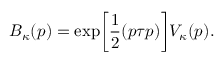<formula> <loc_0><loc_0><loc_500><loc_500>B _ { \kappa } ( p ) = \exp \left [ \frac { 1 } { 2 } ( p \tau p ) \right ] V _ { \kappa } ( p ) .</formula> 